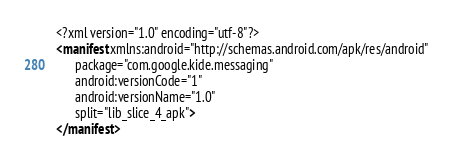Convert code to text. <code><loc_0><loc_0><loc_500><loc_500><_XML_><?xml version="1.0" encoding="utf-8"?>
<manifest xmlns:android="http://schemas.android.com/apk/res/android"
      package="com.google.kide.messaging"
      android:versionCode="1"
      android:versionName="1.0"
      split="lib_slice_4_apk">
</manifest>
</code> 